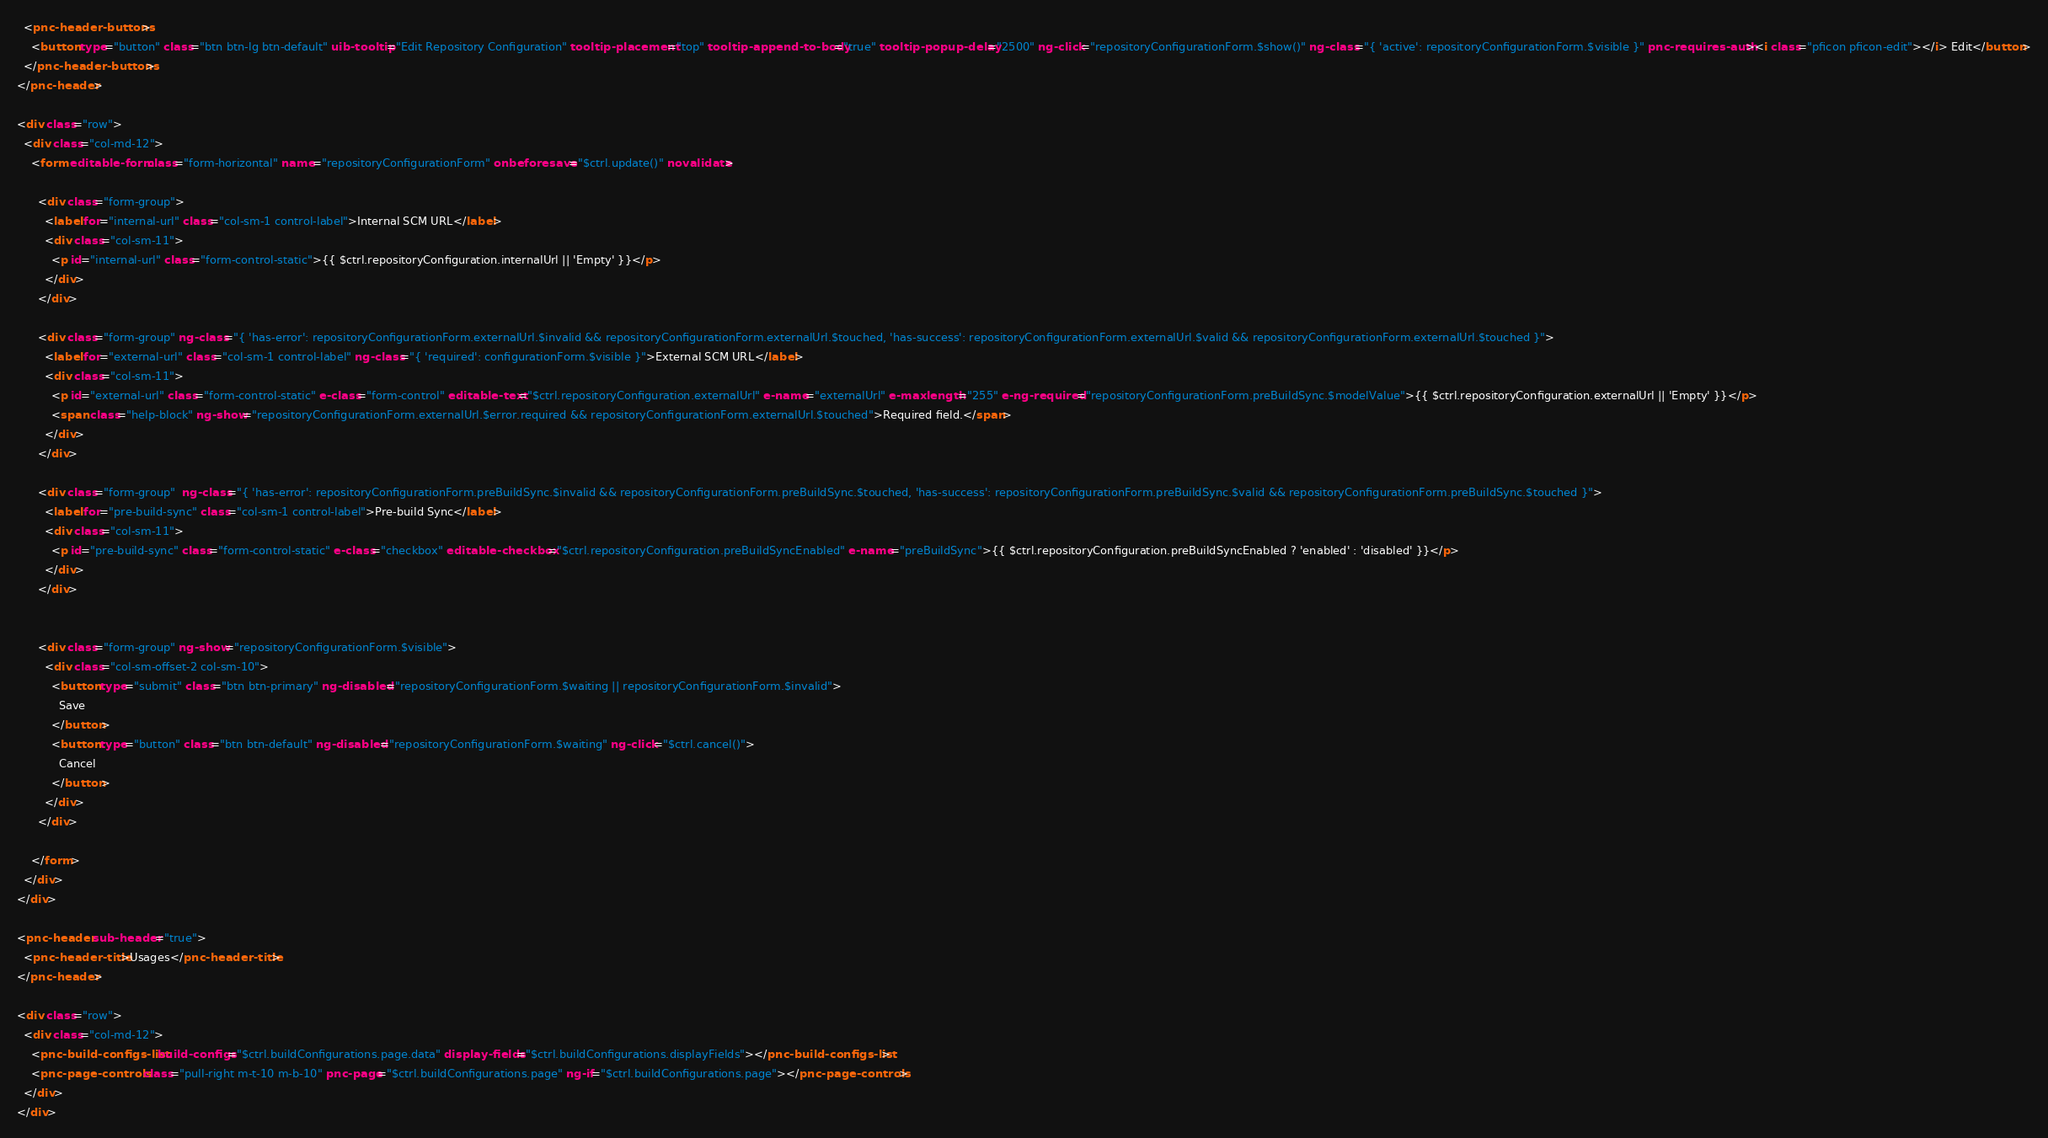<code> <loc_0><loc_0><loc_500><loc_500><_HTML_>  <pnc-header-buttons>
    <button type="button" class="btn btn-lg btn-default" uib-tooltip="Edit Repository Configuration" tooltip-placement="top" tooltip-append-to-body="true" tooltip-popup-delay="2500" ng-click="repositoryConfigurationForm.$show()" ng-class="{ 'active': repositoryConfigurationForm.$visible }" pnc-requires-auth><i class="pficon pficon-edit"></i> Edit</button>
  </pnc-header-buttons>
</pnc-header>

<div class="row">
  <div class="col-md-12">
    <form editable-form class="form-horizontal" name="repositoryConfigurationForm" onbeforesave="$ctrl.update()" novalidate>

      <div class="form-group">
        <label for="internal-url" class="col-sm-1 control-label">Internal SCM URL</label>
        <div class="col-sm-11">
          <p id="internal-url" class="form-control-static">{{ $ctrl.repositoryConfiguration.internalUrl || 'Empty' }}</p>
        </div>
      </div>

      <div class="form-group" ng-class="{ 'has-error': repositoryConfigurationForm.externalUrl.$invalid && repositoryConfigurationForm.externalUrl.$touched, 'has-success': repositoryConfigurationForm.externalUrl.$valid && repositoryConfigurationForm.externalUrl.$touched }">
        <label for="external-url" class="col-sm-1 control-label" ng-class="{ 'required': configurationForm.$visible }">External SCM URL</label>
        <div class="col-sm-11">
          <p id="external-url" class="form-control-static" e-class="form-control" editable-text="$ctrl.repositoryConfiguration.externalUrl" e-name="externalUrl" e-maxlength="255" e-ng-required="repositoryConfigurationForm.preBuildSync.$modelValue">{{ $ctrl.repositoryConfiguration.externalUrl || 'Empty' }}</p>
          <span class="help-block" ng-show="repositoryConfigurationForm.externalUrl.$error.required && repositoryConfigurationForm.externalUrl.$touched">Required field.</span>
        </div>
      </div>

      <div class="form-group"  ng-class="{ 'has-error': repositoryConfigurationForm.preBuildSync.$invalid && repositoryConfigurationForm.preBuildSync.$touched, 'has-success': repositoryConfigurationForm.preBuildSync.$valid && repositoryConfigurationForm.preBuildSync.$touched }">
        <label for="pre-build-sync" class="col-sm-1 control-label">Pre-build Sync</label>
        <div class="col-sm-11">
          <p id="pre-build-sync" class="form-control-static" e-class="checkbox" editable-checkbox="$ctrl.repositoryConfiguration.preBuildSyncEnabled" e-name="preBuildSync">{{ $ctrl.repositoryConfiguration.preBuildSyncEnabled ? 'enabled' : 'disabled' }}</p>
        </div>
      </div>

    
      <div class="form-group" ng-show="repositoryConfigurationForm.$visible">
        <div class="col-sm-offset-2 col-sm-10">
          <button type="submit" class="btn btn-primary" ng-disabled="repositoryConfigurationForm.$waiting || repositoryConfigurationForm.$invalid">
            Save
          </button>
          <button type="button" class="btn btn-default" ng-disabled="repositoryConfigurationForm.$waiting" ng-click="$ctrl.cancel()">
            Cancel
          </button>
        </div>
      </div>
      
    </form>
  </div>
</div>

<pnc-header sub-header="true">
  <pnc-header-title>Usages</pnc-header-title>
</pnc-header>

<div class="row">
  <div class="col-md-12">
    <pnc-build-configs-list build-configs="$ctrl.buildConfigurations.page.data" display-fields="$ctrl.buildConfigurations.displayFields"></pnc-build-configs-list>
    <pnc-page-controls class="pull-right m-t-10 m-b-10" pnc-page="$ctrl.buildConfigurations.page" ng-if="$ctrl.buildConfigurations.page"></pnc-page-controls>
  </div>
</div>
</code> 